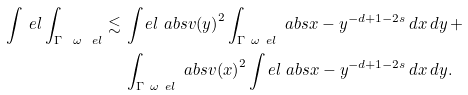Convert formula to latex. <formula><loc_0><loc_0><loc_500><loc_500>\int _ { \ } e l \int _ { \Gamma \ \omega _ { \ } e l } \lesssim \, & \int _ { \ } e l \ a b s { v ( y ) } ^ { 2 } \int _ { \Gamma \ \omega _ { \ } e l } \ a b s { x - y } ^ { - d + 1 - 2 s } \, d x \, d y \, + \\ & \int _ { \Gamma \ \omega _ { \ } e l } \ a b s { v ( x ) } ^ { 2 } \int _ { \ } e l \ a b s { x - y } ^ { - d + 1 - 2 s } \, d x \, d y .</formula> 